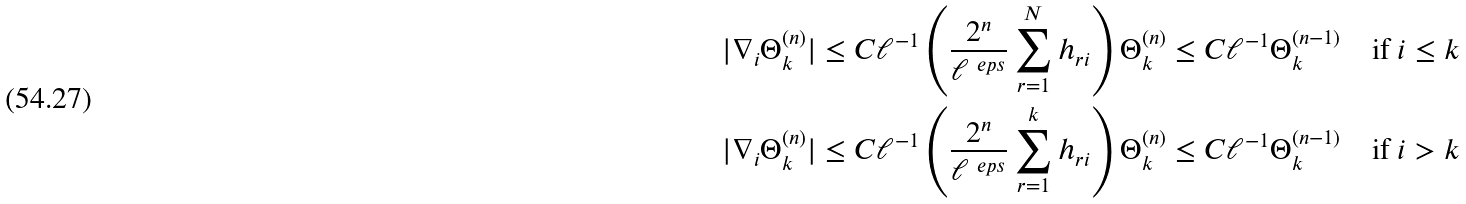Convert formula to latex. <formula><loc_0><loc_0><loc_500><loc_500>| \nabla _ { i } & \Theta _ { k } ^ { ( n ) } | \leq C \ell ^ { - 1 } \left ( \frac { 2 ^ { n } } { \ell ^ { \ e p s } } \sum _ { r = 1 } ^ { N } h _ { r i } \right ) \Theta _ { k } ^ { ( n ) } \leq C \ell ^ { - 1 } \Theta _ { k } ^ { ( n - 1 ) } \quad \text {if } i \leq k \\ | \nabla _ { i } & \Theta _ { k } ^ { ( n ) } | \leq C \ell ^ { - 1 } \left ( \frac { 2 ^ { n } } { \ell ^ { \ e p s } } \sum _ { r = 1 } ^ { k } h _ { r i } \right ) \Theta _ { k } ^ { ( n ) } \leq C \ell ^ { - 1 } \Theta _ { k } ^ { ( n - 1 ) } \quad \text {if } i > k</formula> 